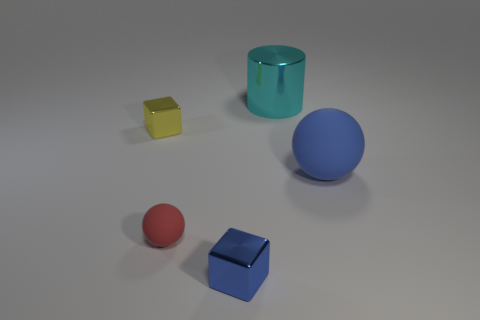How many objects are there, and can you name their colors? There are four objects in the image. Starting from the left, there is a small yellow cube, a red sphere, a blue cube, and a cyan cylinder. 